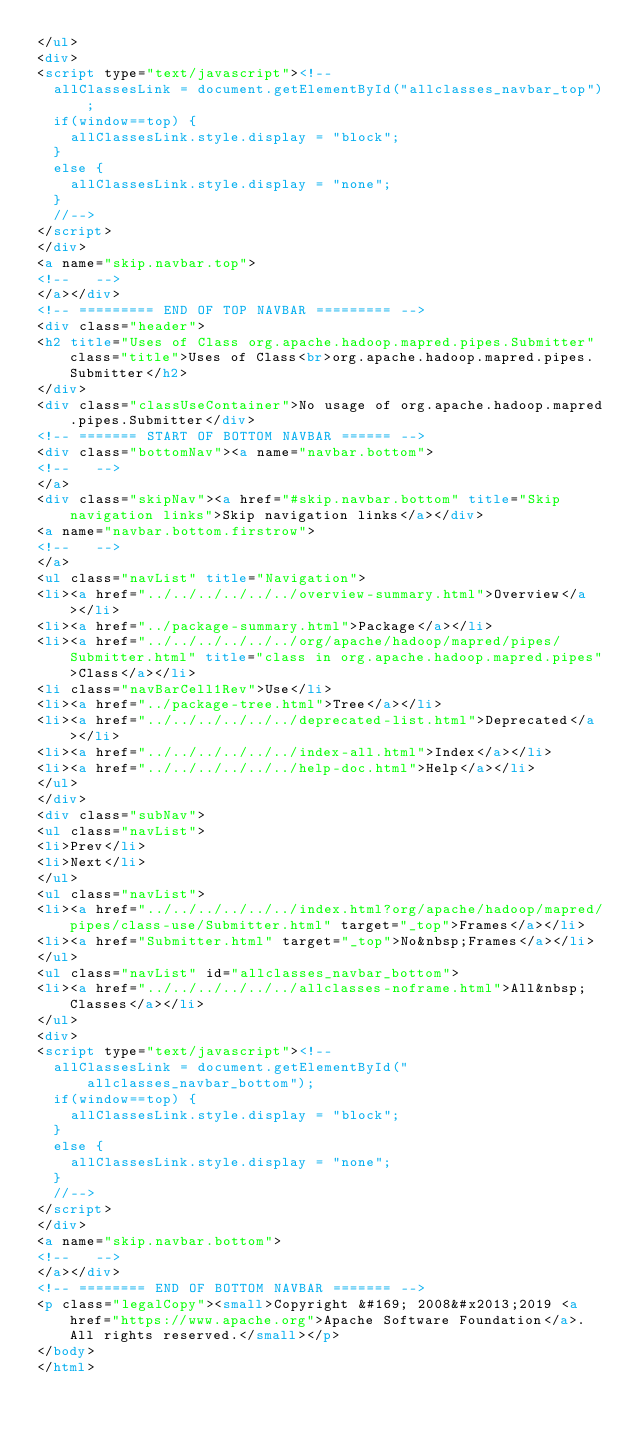<code> <loc_0><loc_0><loc_500><loc_500><_HTML_></ul>
<div>
<script type="text/javascript"><!--
  allClassesLink = document.getElementById("allclasses_navbar_top");
  if(window==top) {
    allClassesLink.style.display = "block";
  }
  else {
    allClassesLink.style.display = "none";
  }
  //-->
</script>
</div>
<a name="skip.navbar.top">
<!--   -->
</a></div>
<!-- ========= END OF TOP NAVBAR ========= -->
<div class="header">
<h2 title="Uses of Class org.apache.hadoop.mapred.pipes.Submitter" class="title">Uses of Class<br>org.apache.hadoop.mapred.pipes.Submitter</h2>
</div>
<div class="classUseContainer">No usage of org.apache.hadoop.mapred.pipes.Submitter</div>
<!-- ======= START OF BOTTOM NAVBAR ====== -->
<div class="bottomNav"><a name="navbar.bottom">
<!--   -->
</a>
<div class="skipNav"><a href="#skip.navbar.bottom" title="Skip navigation links">Skip navigation links</a></div>
<a name="navbar.bottom.firstrow">
<!--   -->
</a>
<ul class="navList" title="Navigation">
<li><a href="../../../../../../overview-summary.html">Overview</a></li>
<li><a href="../package-summary.html">Package</a></li>
<li><a href="../../../../../../org/apache/hadoop/mapred/pipes/Submitter.html" title="class in org.apache.hadoop.mapred.pipes">Class</a></li>
<li class="navBarCell1Rev">Use</li>
<li><a href="../package-tree.html">Tree</a></li>
<li><a href="../../../../../../deprecated-list.html">Deprecated</a></li>
<li><a href="../../../../../../index-all.html">Index</a></li>
<li><a href="../../../../../../help-doc.html">Help</a></li>
</ul>
</div>
<div class="subNav">
<ul class="navList">
<li>Prev</li>
<li>Next</li>
</ul>
<ul class="navList">
<li><a href="../../../../../../index.html?org/apache/hadoop/mapred/pipes/class-use/Submitter.html" target="_top">Frames</a></li>
<li><a href="Submitter.html" target="_top">No&nbsp;Frames</a></li>
</ul>
<ul class="navList" id="allclasses_navbar_bottom">
<li><a href="../../../../../../allclasses-noframe.html">All&nbsp;Classes</a></li>
</ul>
<div>
<script type="text/javascript"><!--
  allClassesLink = document.getElementById("allclasses_navbar_bottom");
  if(window==top) {
    allClassesLink.style.display = "block";
  }
  else {
    allClassesLink.style.display = "none";
  }
  //-->
</script>
</div>
<a name="skip.navbar.bottom">
<!--   -->
</a></div>
<!-- ======== END OF BOTTOM NAVBAR ======= -->
<p class="legalCopy"><small>Copyright &#169; 2008&#x2013;2019 <a href="https://www.apache.org">Apache Software Foundation</a>. All rights reserved.</small></p>
</body>
</html>
</code> 